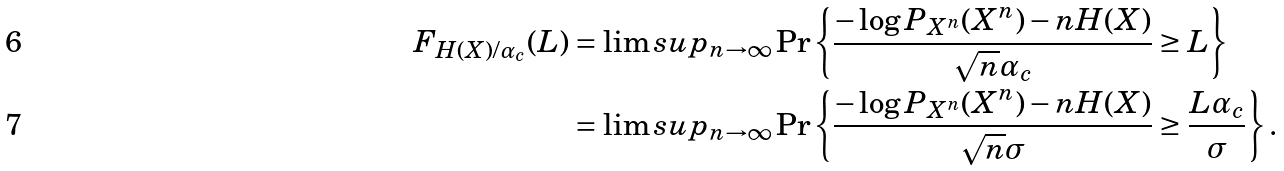<formula> <loc_0><loc_0><loc_500><loc_500>F _ { H ( X ) / \alpha _ { c } } ( L ) & = \lim s u p _ { n \to \infty } \Pr \left \{ \frac { - \log P _ { X ^ { n } } ( X ^ { n } ) - n H ( X ) } { \sqrt { n } \alpha _ { c } } \geq { L } \right \} \\ & = \lim s u p _ { n \to \infty } \Pr \left \{ \frac { - \log P _ { X ^ { n } } ( X ^ { n } ) - n H ( X ) } { \sqrt { n } \sigma } \geq \frac { L \alpha _ { c } } { \sigma } \right \} .</formula> 